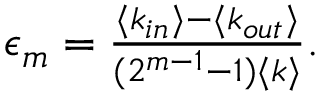Convert formula to latex. <formula><loc_0><loc_0><loc_500><loc_500>\begin{array} { r } { \epsilon _ { m } = \frac { \langle k _ { i n } \rangle - \langle k _ { o u t } \rangle } { ( 2 ^ { m - 1 } - 1 ) \langle k \rangle } . } \end{array}</formula> 